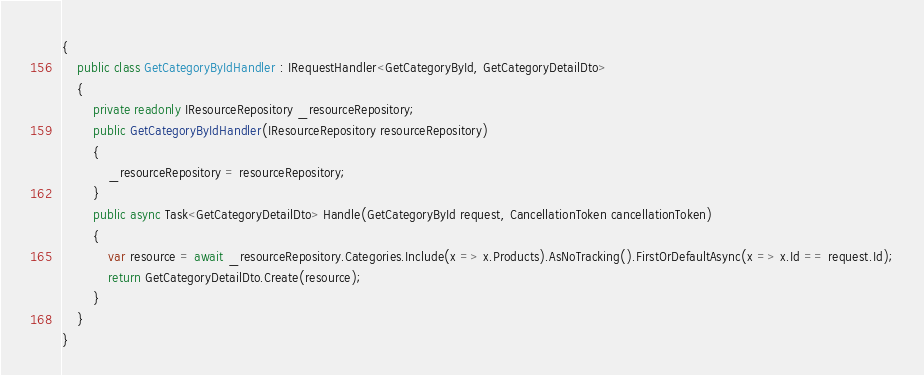Convert code to text. <code><loc_0><loc_0><loc_500><loc_500><_C#_>{
    public class GetCategoryByIdHandler : IRequestHandler<GetCategoryById, GetCategoryDetailDto>
    {
        private readonly IResourceRepository _resourceRepository;
        public GetCategoryByIdHandler(IResourceRepository resourceRepository)
        {
            _resourceRepository = resourceRepository;
        }
        public async Task<GetCategoryDetailDto> Handle(GetCategoryById request, CancellationToken cancellationToken)
        {
            var resource = await _resourceRepository.Categories.Include(x => x.Products).AsNoTracking().FirstOrDefaultAsync(x => x.Id == request.Id);
            return GetCategoryDetailDto.Create(resource);
        }
    }
}</code> 